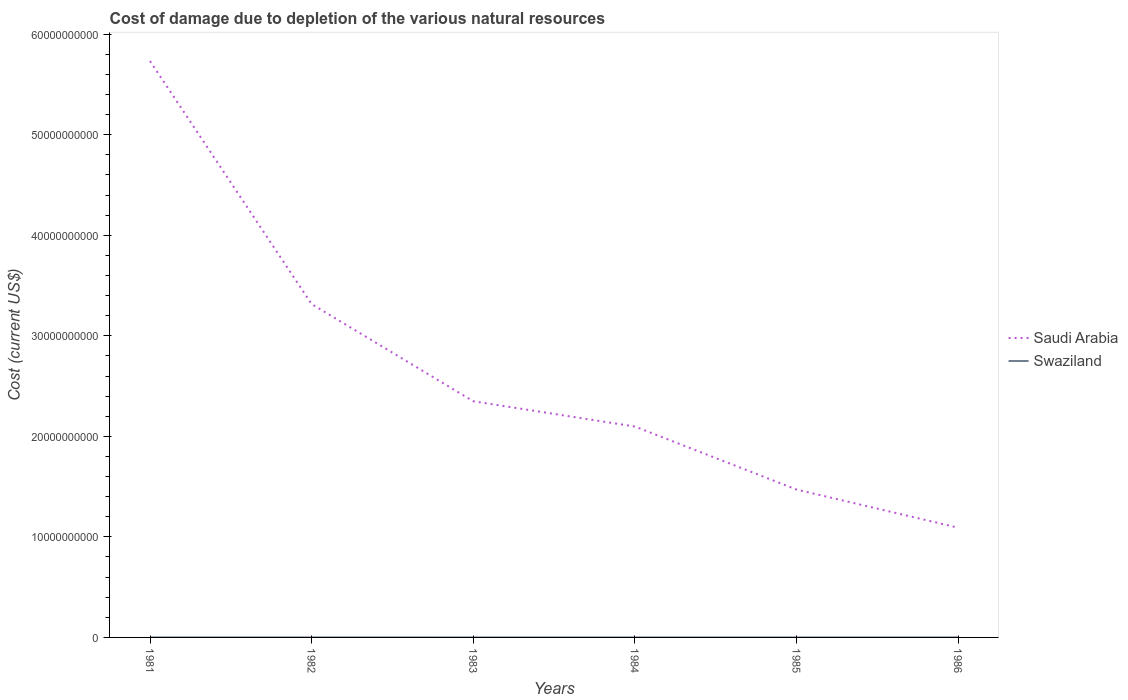Is the number of lines equal to the number of legend labels?
Your response must be concise. Yes. Across all years, what is the maximum cost of damage caused due to the depletion of various natural resources in Saudi Arabia?
Ensure brevity in your answer.  1.09e+1. In which year was the cost of damage caused due to the depletion of various natural resources in Saudi Arabia maximum?
Provide a short and direct response. 1986. What is the total cost of damage caused due to the depletion of various natural resources in Swaziland in the graph?
Provide a short and direct response. -3.10e+05. What is the difference between the highest and the second highest cost of damage caused due to the depletion of various natural resources in Swaziland?
Make the answer very short. 1.68e+06. How many lines are there?
Your answer should be very brief. 2. How many years are there in the graph?
Give a very brief answer. 6. What is the difference between two consecutive major ticks on the Y-axis?
Your response must be concise. 1.00e+1. Are the values on the major ticks of Y-axis written in scientific E-notation?
Your answer should be very brief. No. Where does the legend appear in the graph?
Your response must be concise. Center right. How are the legend labels stacked?
Offer a terse response. Vertical. What is the title of the graph?
Your response must be concise. Cost of damage due to depletion of the various natural resources. Does "World" appear as one of the legend labels in the graph?
Ensure brevity in your answer.  No. What is the label or title of the X-axis?
Offer a terse response. Years. What is the label or title of the Y-axis?
Provide a succinct answer. Cost (current US$). What is the Cost (current US$) of Saudi Arabia in 1981?
Keep it short and to the point. 5.73e+1. What is the Cost (current US$) of Swaziland in 1981?
Your answer should be compact. 1.77e+06. What is the Cost (current US$) of Saudi Arabia in 1982?
Make the answer very short. 3.32e+1. What is the Cost (current US$) in Swaziland in 1982?
Your answer should be compact. 1.89e+06. What is the Cost (current US$) of Saudi Arabia in 1983?
Your answer should be compact. 2.35e+1. What is the Cost (current US$) in Swaziland in 1983?
Provide a succinct answer. 5.24e+05. What is the Cost (current US$) in Saudi Arabia in 1984?
Offer a very short reply. 2.10e+1. What is the Cost (current US$) in Swaziland in 1984?
Your answer should be very brief. 3.92e+05. What is the Cost (current US$) in Saudi Arabia in 1985?
Your answer should be compact. 1.47e+1. What is the Cost (current US$) of Swaziland in 1985?
Offer a very short reply. 7.02e+05. What is the Cost (current US$) in Saudi Arabia in 1986?
Offer a terse response. 1.09e+1. What is the Cost (current US$) in Swaziland in 1986?
Keep it short and to the point. 2.18e+05. Across all years, what is the maximum Cost (current US$) in Saudi Arabia?
Keep it short and to the point. 5.73e+1. Across all years, what is the maximum Cost (current US$) in Swaziland?
Offer a very short reply. 1.89e+06. Across all years, what is the minimum Cost (current US$) of Saudi Arabia?
Offer a very short reply. 1.09e+1. Across all years, what is the minimum Cost (current US$) in Swaziland?
Your answer should be compact. 2.18e+05. What is the total Cost (current US$) in Saudi Arabia in the graph?
Your answer should be compact. 1.61e+11. What is the total Cost (current US$) in Swaziland in the graph?
Offer a very short reply. 5.50e+06. What is the difference between the Cost (current US$) in Saudi Arabia in 1981 and that in 1982?
Offer a very short reply. 2.42e+1. What is the difference between the Cost (current US$) of Swaziland in 1981 and that in 1982?
Offer a terse response. -1.26e+05. What is the difference between the Cost (current US$) in Saudi Arabia in 1981 and that in 1983?
Your response must be concise. 3.38e+1. What is the difference between the Cost (current US$) of Swaziland in 1981 and that in 1983?
Give a very brief answer. 1.24e+06. What is the difference between the Cost (current US$) of Saudi Arabia in 1981 and that in 1984?
Your response must be concise. 3.63e+1. What is the difference between the Cost (current US$) of Swaziland in 1981 and that in 1984?
Give a very brief answer. 1.38e+06. What is the difference between the Cost (current US$) of Saudi Arabia in 1981 and that in 1985?
Offer a very short reply. 4.26e+1. What is the difference between the Cost (current US$) in Swaziland in 1981 and that in 1985?
Ensure brevity in your answer.  1.07e+06. What is the difference between the Cost (current US$) of Saudi Arabia in 1981 and that in 1986?
Your answer should be very brief. 4.64e+1. What is the difference between the Cost (current US$) in Swaziland in 1981 and that in 1986?
Provide a succinct answer. 1.55e+06. What is the difference between the Cost (current US$) of Saudi Arabia in 1982 and that in 1983?
Ensure brevity in your answer.  9.66e+09. What is the difference between the Cost (current US$) in Swaziland in 1982 and that in 1983?
Ensure brevity in your answer.  1.37e+06. What is the difference between the Cost (current US$) of Saudi Arabia in 1982 and that in 1984?
Ensure brevity in your answer.  1.22e+1. What is the difference between the Cost (current US$) of Swaziland in 1982 and that in 1984?
Make the answer very short. 1.50e+06. What is the difference between the Cost (current US$) of Saudi Arabia in 1982 and that in 1985?
Provide a short and direct response. 1.84e+1. What is the difference between the Cost (current US$) in Swaziland in 1982 and that in 1985?
Offer a very short reply. 1.19e+06. What is the difference between the Cost (current US$) in Saudi Arabia in 1982 and that in 1986?
Offer a terse response. 2.22e+1. What is the difference between the Cost (current US$) in Swaziland in 1982 and that in 1986?
Provide a short and direct response. 1.68e+06. What is the difference between the Cost (current US$) of Saudi Arabia in 1983 and that in 1984?
Keep it short and to the point. 2.51e+09. What is the difference between the Cost (current US$) in Swaziland in 1983 and that in 1984?
Provide a short and direct response. 1.32e+05. What is the difference between the Cost (current US$) of Saudi Arabia in 1983 and that in 1985?
Ensure brevity in your answer.  8.78e+09. What is the difference between the Cost (current US$) in Swaziland in 1983 and that in 1985?
Provide a succinct answer. -1.78e+05. What is the difference between the Cost (current US$) of Saudi Arabia in 1983 and that in 1986?
Give a very brief answer. 1.26e+1. What is the difference between the Cost (current US$) in Swaziland in 1983 and that in 1986?
Your answer should be very brief. 3.06e+05. What is the difference between the Cost (current US$) in Saudi Arabia in 1984 and that in 1985?
Your answer should be very brief. 6.27e+09. What is the difference between the Cost (current US$) in Swaziland in 1984 and that in 1985?
Provide a short and direct response. -3.10e+05. What is the difference between the Cost (current US$) in Saudi Arabia in 1984 and that in 1986?
Offer a terse response. 1.01e+1. What is the difference between the Cost (current US$) in Swaziland in 1984 and that in 1986?
Your response must be concise. 1.75e+05. What is the difference between the Cost (current US$) of Saudi Arabia in 1985 and that in 1986?
Ensure brevity in your answer.  3.79e+09. What is the difference between the Cost (current US$) of Swaziland in 1985 and that in 1986?
Provide a short and direct response. 4.84e+05. What is the difference between the Cost (current US$) of Saudi Arabia in 1981 and the Cost (current US$) of Swaziland in 1982?
Keep it short and to the point. 5.73e+1. What is the difference between the Cost (current US$) of Saudi Arabia in 1981 and the Cost (current US$) of Swaziland in 1983?
Offer a very short reply. 5.73e+1. What is the difference between the Cost (current US$) of Saudi Arabia in 1981 and the Cost (current US$) of Swaziland in 1984?
Ensure brevity in your answer.  5.73e+1. What is the difference between the Cost (current US$) in Saudi Arabia in 1981 and the Cost (current US$) in Swaziland in 1985?
Provide a succinct answer. 5.73e+1. What is the difference between the Cost (current US$) in Saudi Arabia in 1981 and the Cost (current US$) in Swaziland in 1986?
Ensure brevity in your answer.  5.73e+1. What is the difference between the Cost (current US$) of Saudi Arabia in 1982 and the Cost (current US$) of Swaziland in 1983?
Make the answer very short. 3.32e+1. What is the difference between the Cost (current US$) in Saudi Arabia in 1982 and the Cost (current US$) in Swaziland in 1984?
Keep it short and to the point. 3.32e+1. What is the difference between the Cost (current US$) of Saudi Arabia in 1982 and the Cost (current US$) of Swaziland in 1985?
Make the answer very short. 3.32e+1. What is the difference between the Cost (current US$) in Saudi Arabia in 1982 and the Cost (current US$) in Swaziland in 1986?
Give a very brief answer. 3.32e+1. What is the difference between the Cost (current US$) of Saudi Arabia in 1983 and the Cost (current US$) of Swaziland in 1984?
Provide a short and direct response. 2.35e+1. What is the difference between the Cost (current US$) of Saudi Arabia in 1983 and the Cost (current US$) of Swaziland in 1985?
Your answer should be very brief. 2.35e+1. What is the difference between the Cost (current US$) in Saudi Arabia in 1983 and the Cost (current US$) in Swaziland in 1986?
Your response must be concise. 2.35e+1. What is the difference between the Cost (current US$) of Saudi Arabia in 1984 and the Cost (current US$) of Swaziland in 1985?
Keep it short and to the point. 2.10e+1. What is the difference between the Cost (current US$) of Saudi Arabia in 1984 and the Cost (current US$) of Swaziland in 1986?
Provide a short and direct response. 2.10e+1. What is the difference between the Cost (current US$) of Saudi Arabia in 1985 and the Cost (current US$) of Swaziland in 1986?
Your answer should be compact. 1.47e+1. What is the average Cost (current US$) of Saudi Arabia per year?
Ensure brevity in your answer.  2.68e+1. What is the average Cost (current US$) in Swaziland per year?
Your answer should be very brief. 9.16e+05. In the year 1981, what is the difference between the Cost (current US$) in Saudi Arabia and Cost (current US$) in Swaziland?
Your answer should be very brief. 5.73e+1. In the year 1982, what is the difference between the Cost (current US$) of Saudi Arabia and Cost (current US$) of Swaziland?
Keep it short and to the point. 3.31e+1. In the year 1983, what is the difference between the Cost (current US$) in Saudi Arabia and Cost (current US$) in Swaziland?
Provide a succinct answer. 2.35e+1. In the year 1984, what is the difference between the Cost (current US$) of Saudi Arabia and Cost (current US$) of Swaziland?
Keep it short and to the point. 2.10e+1. In the year 1985, what is the difference between the Cost (current US$) of Saudi Arabia and Cost (current US$) of Swaziland?
Ensure brevity in your answer.  1.47e+1. In the year 1986, what is the difference between the Cost (current US$) in Saudi Arabia and Cost (current US$) in Swaziland?
Keep it short and to the point. 1.09e+1. What is the ratio of the Cost (current US$) of Saudi Arabia in 1981 to that in 1982?
Provide a short and direct response. 1.73. What is the ratio of the Cost (current US$) in Swaziland in 1981 to that in 1982?
Offer a very short reply. 0.93. What is the ratio of the Cost (current US$) in Saudi Arabia in 1981 to that in 1983?
Give a very brief answer. 2.44. What is the ratio of the Cost (current US$) of Swaziland in 1981 to that in 1983?
Offer a very short reply. 3.38. What is the ratio of the Cost (current US$) in Saudi Arabia in 1981 to that in 1984?
Offer a terse response. 2.73. What is the ratio of the Cost (current US$) of Swaziland in 1981 to that in 1984?
Your answer should be compact. 4.51. What is the ratio of the Cost (current US$) in Saudi Arabia in 1981 to that in 1985?
Provide a succinct answer. 3.9. What is the ratio of the Cost (current US$) in Swaziland in 1981 to that in 1985?
Provide a succinct answer. 2.52. What is the ratio of the Cost (current US$) of Saudi Arabia in 1981 to that in 1986?
Offer a terse response. 5.25. What is the ratio of the Cost (current US$) of Swaziland in 1981 to that in 1986?
Make the answer very short. 8.13. What is the ratio of the Cost (current US$) in Saudi Arabia in 1982 to that in 1983?
Keep it short and to the point. 1.41. What is the ratio of the Cost (current US$) in Swaziland in 1982 to that in 1983?
Your answer should be very brief. 3.62. What is the ratio of the Cost (current US$) in Saudi Arabia in 1982 to that in 1984?
Provide a short and direct response. 1.58. What is the ratio of the Cost (current US$) of Swaziland in 1982 to that in 1984?
Your answer should be compact. 4.83. What is the ratio of the Cost (current US$) of Saudi Arabia in 1982 to that in 1985?
Provide a short and direct response. 2.25. What is the ratio of the Cost (current US$) of Swaziland in 1982 to that in 1985?
Keep it short and to the point. 2.7. What is the ratio of the Cost (current US$) of Saudi Arabia in 1982 to that in 1986?
Make the answer very short. 3.04. What is the ratio of the Cost (current US$) of Swaziland in 1982 to that in 1986?
Provide a short and direct response. 8.71. What is the ratio of the Cost (current US$) of Saudi Arabia in 1983 to that in 1984?
Make the answer very short. 1.12. What is the ratio of the Cost (current US$) in Swaziland in 1983 to that in 1984?
Give a very brief answer. 1.34. What is the ratio of the Cost (current US$) in Saudi Arabia in 1983 to that in 1985?
Provide a short and direct response. 1.6. What is the ratio of the Cost (current US$) in Swaziland in 1983 to that in 1985?
Provide a succinct answer. 0.75. What is the ratio of the Cost (current US$) in Saudi Arabia in 1983 to that in 1986?
Provide a short and direct response. 2.15. What is the ratio of the Cost (current US$) of Swaziland in 1983 to that in 1986?
Offer a very short reply. 2.41. What is the ratio of the Cost (current US$) of Saudi Arabia in 1984 to that in 1985?
Ensure brevity in your answer.  1.43. What is the ratio of the Cost (current US$) in Swaziland in 1984 to that in 1985?
Ensure brevity in your answer.  0.56. What is the ratio of the Cost (current US$) in Saudi Arabia in 1984 to that in 1986?
Your answer should be very brief. 1.92. What is the ratio of the Cost (current US$) of Swaziland in 1984 to that in 1986?
Provide a short and direct response. 1.8. What is the ratio of the Cost (current US$) of Saudi Arabia in 1985 to that in 1986?
Give a very brief answer. 1.35. What is the ratio of the Cost (current US$) of Swaziland in 1985 to that in 1986?
Provide a short and direct response. 3.23. What is the difference between the highest and the second highest Cost (current US$) in Saudi Arabia?
Offer a very short reply. 2.42e+1. What is the difference between the highest and the second highest Cost (current US$) of Swaziland?
Your answer should be compact. 1.26e+05. What is the difference between the highest and the lowest Cost (current US$) in Saudi Arabia?
Your answer should be compact. 4.64e+1. What is the difference between the highest and the lowest Cost (current US$) of Swaziland?
Keep it short and to the point. 1.68e+06. 